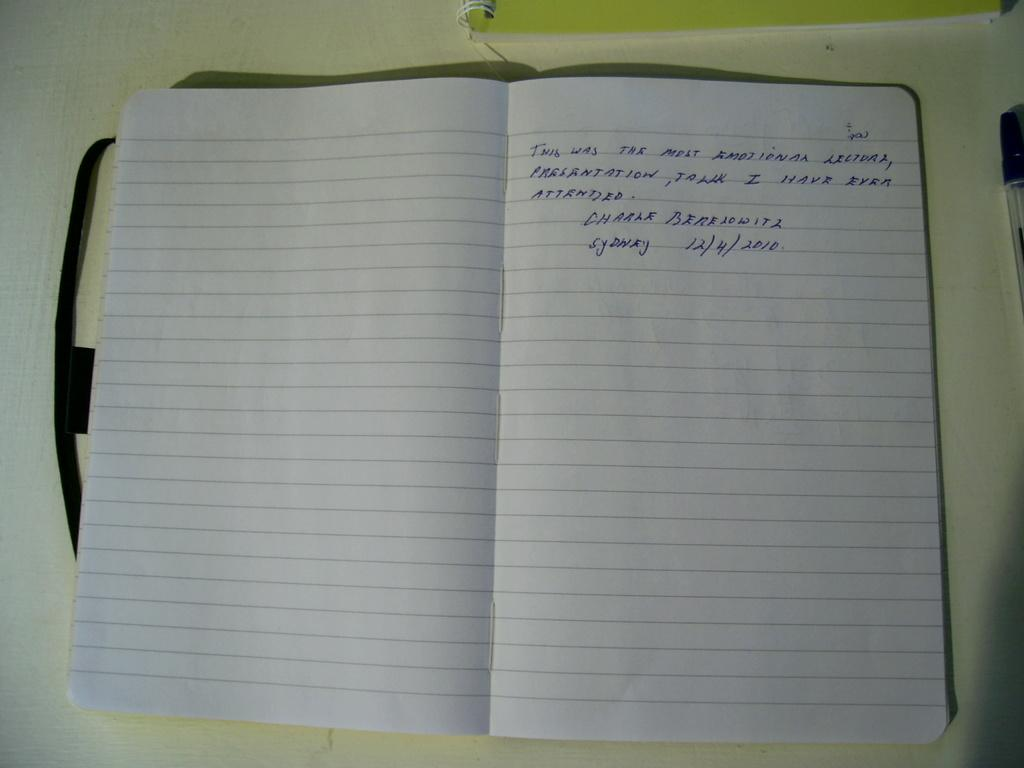<image>
Offer a succinct explanation of the picture presented. In a notebook, Charle Berelowitz has left an message. 